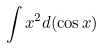<formula> <loc_0><loc_0><loc_500><loc_500>\int x ^ { 2 } d ( \cos x )</formula> 